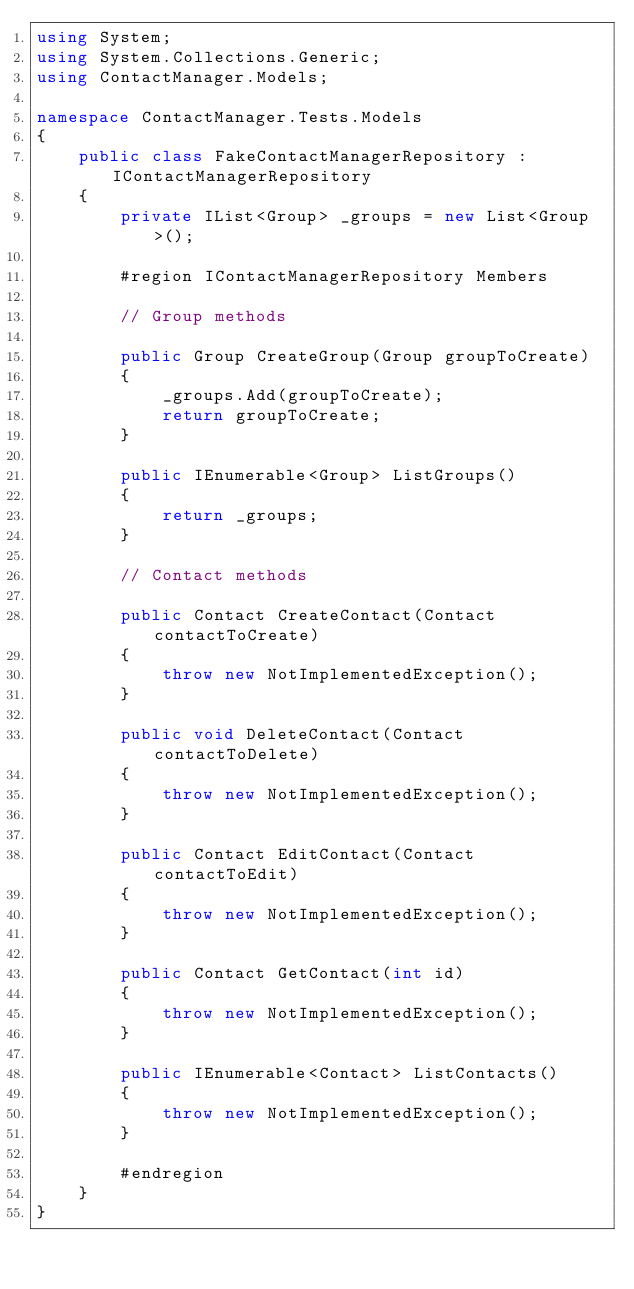<code> <loc_0><loc_0><loc_500><loc_500><_C#_>using System;
using System.Collections.Generic;
using ContactManager.Models;

namespace ContactManager.Tests.Models
{
    public class FakeContactManagerRepository : IContactManagerRepository
    {
        private IList<Group> _groups = new List<Group>(); 
        
        #region IContactManagerRepository Members

        // Group methods

        public Group CreateGroup(Group groupToCreate)
        {
            _groups.Add(groupToCreate);
            return groupToCreate;
        }

        public IEnumerable<Group> ListGroups()
        {
            return _groups;
        }

        // Contact methods
        
        public Contact CreateContact(Contact contactToCreate)
        {
            throw new NotImplementedException();
        }

        public void DeleteContact(Contact contactToDelete)
        {
            throw new NotImplementedException();
        }

        public Contact EditContact(Contact contactToEdit)
        {
            throw new NotImplementedException();
        }

        public Contact GetContact(int id)
        {
            throw new NotImplementedException();
        }

        public IEnumerable<Contact> ListContacts()
        {
            throw new NotImplementedException();
        }

        #endregion
    }
}</code> 